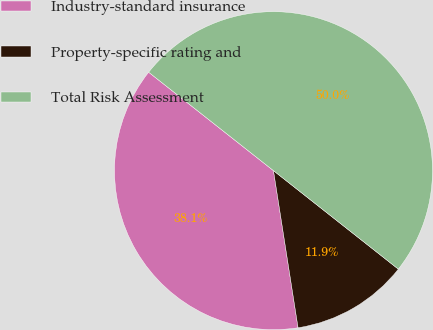Convert chart. <chart><loc_0><loc_0><loc_500><loc_500><pie_chart><fcel>Industry-standard insurance<fcel>Property-specific rating and<fcel>Total Risk Assessment<nl><fcel>38.1%<fcel>11.9%<fcel>50.0%<nl></chart> 